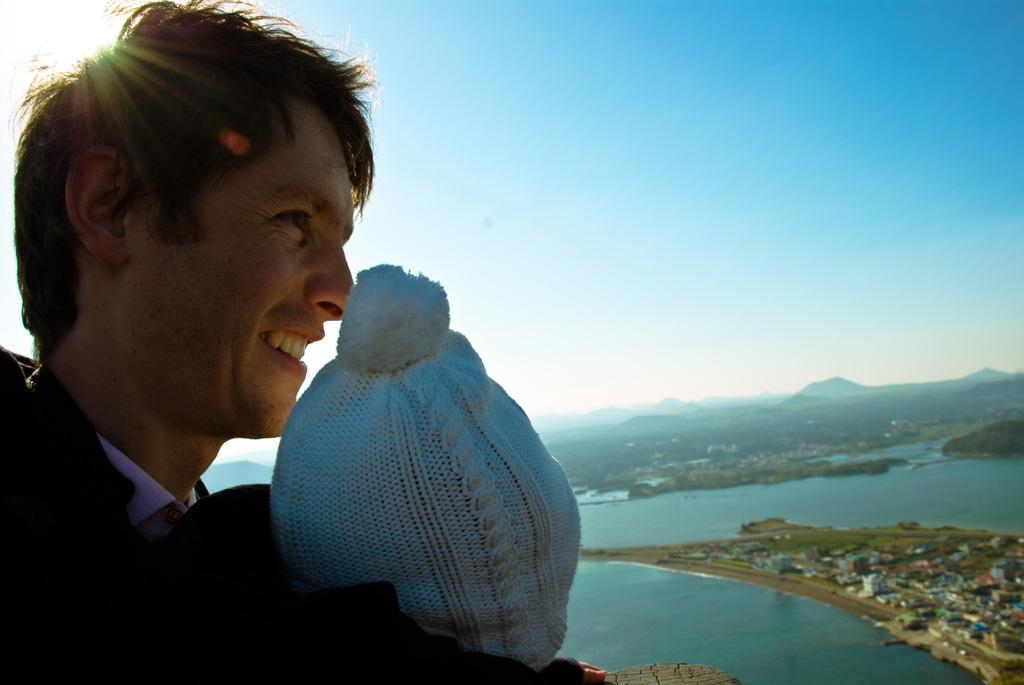What is located on the left side of the image? There is a man on the left side of the image. What is the man doing in the image? The man is smiling in the image. Who is in front of the man? There is a kid in front of the man. What can be seen on the left side of the image besides the man? There is water visible on the left side of the image. What is visible at the top of the image? The sky is visible at the top of the image. What type of behavior do the chickens exhibit in the image? There are no chickens present in the image, so it is not possible to determine their behavior. 